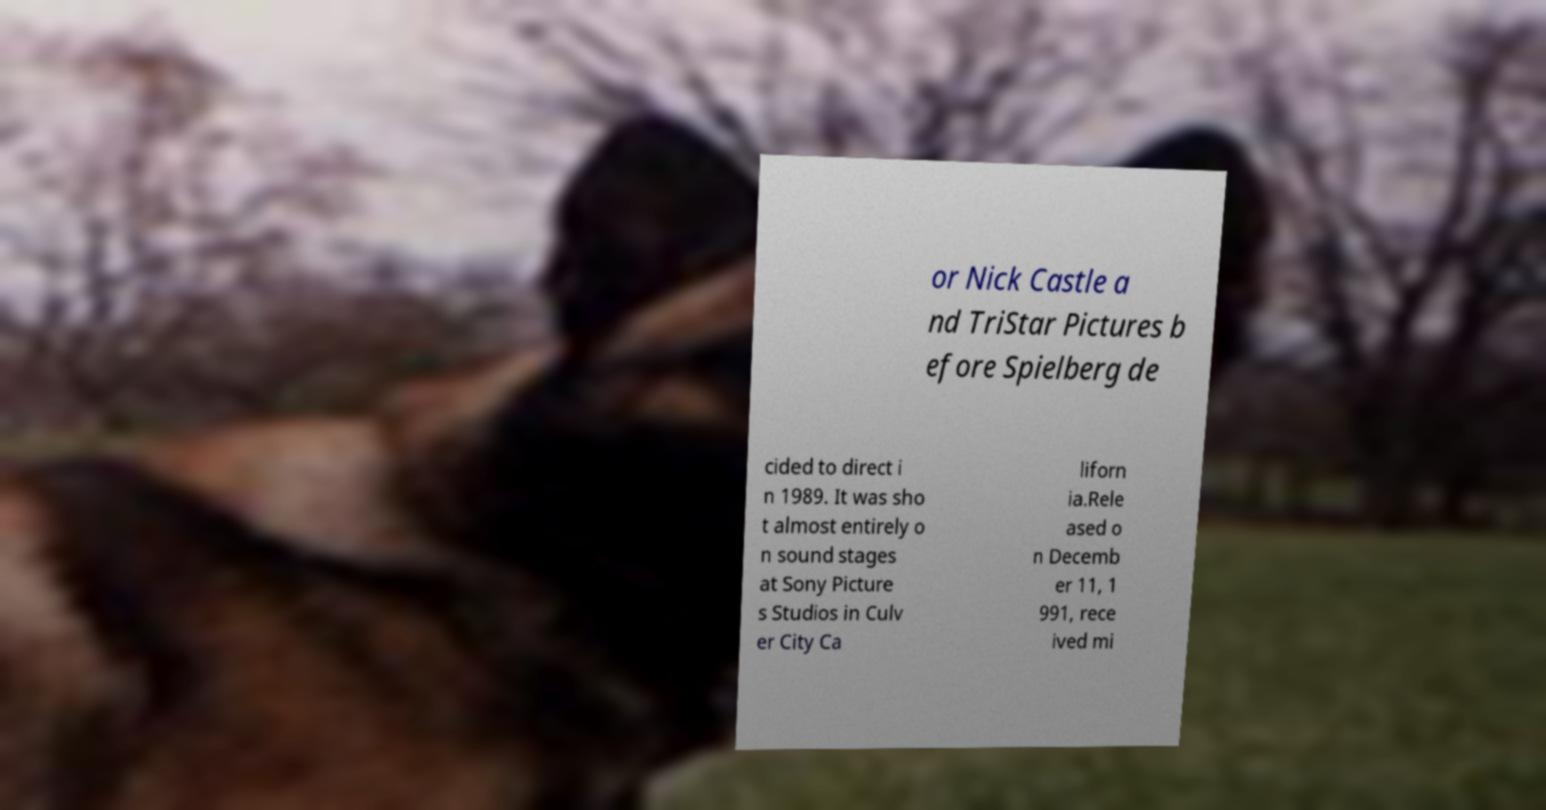Please read and relay the text visible in this image. What does it say? or Nick Castle a nd TriStar Pictures b efore Spielberg de cided to direct i n 1989. It was sho t almost entirely o n sound stages at Sony Picture s Studios in Culv er City Ca liforn ia.Rele ased o n Decemb er 11, 1 991, rece ived mi 